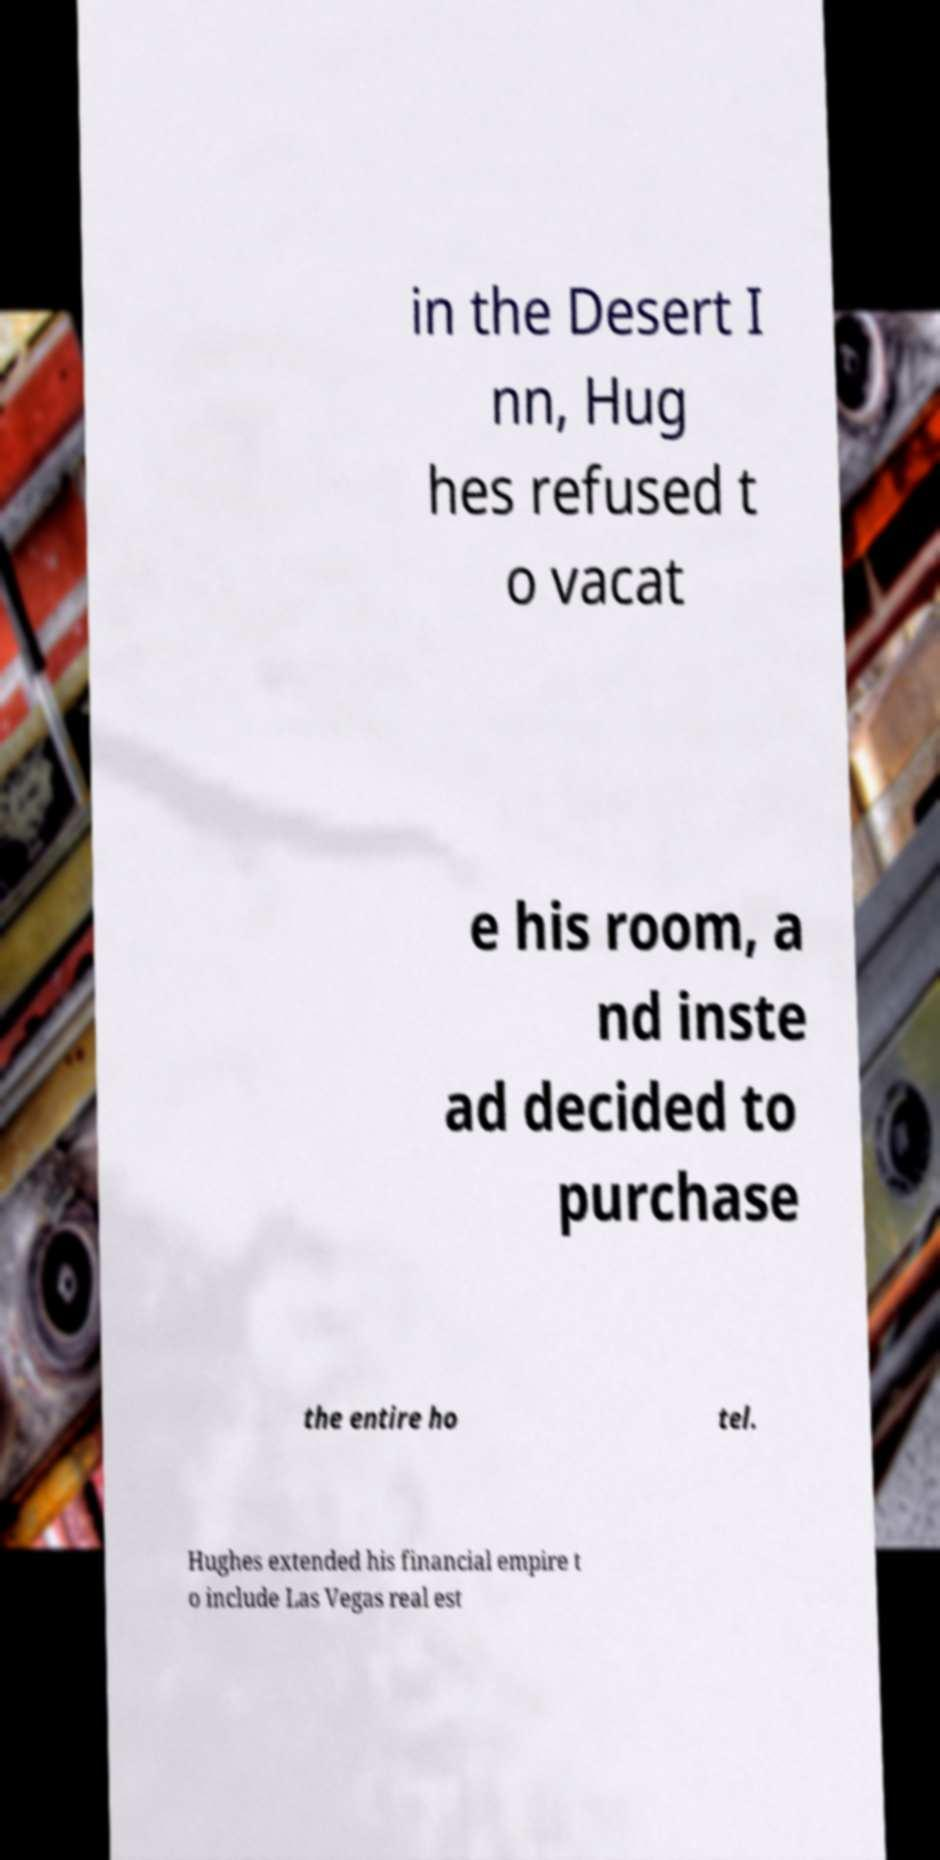What messages or text are displayed in this image? I need them in a readable, typed format. in the Desert I nn, Hug hes refused t o vacat e his room, a nd inste ad decided to purchase the entire ho tel. Hughes extended his financial empire t o include Las Vegas real est 